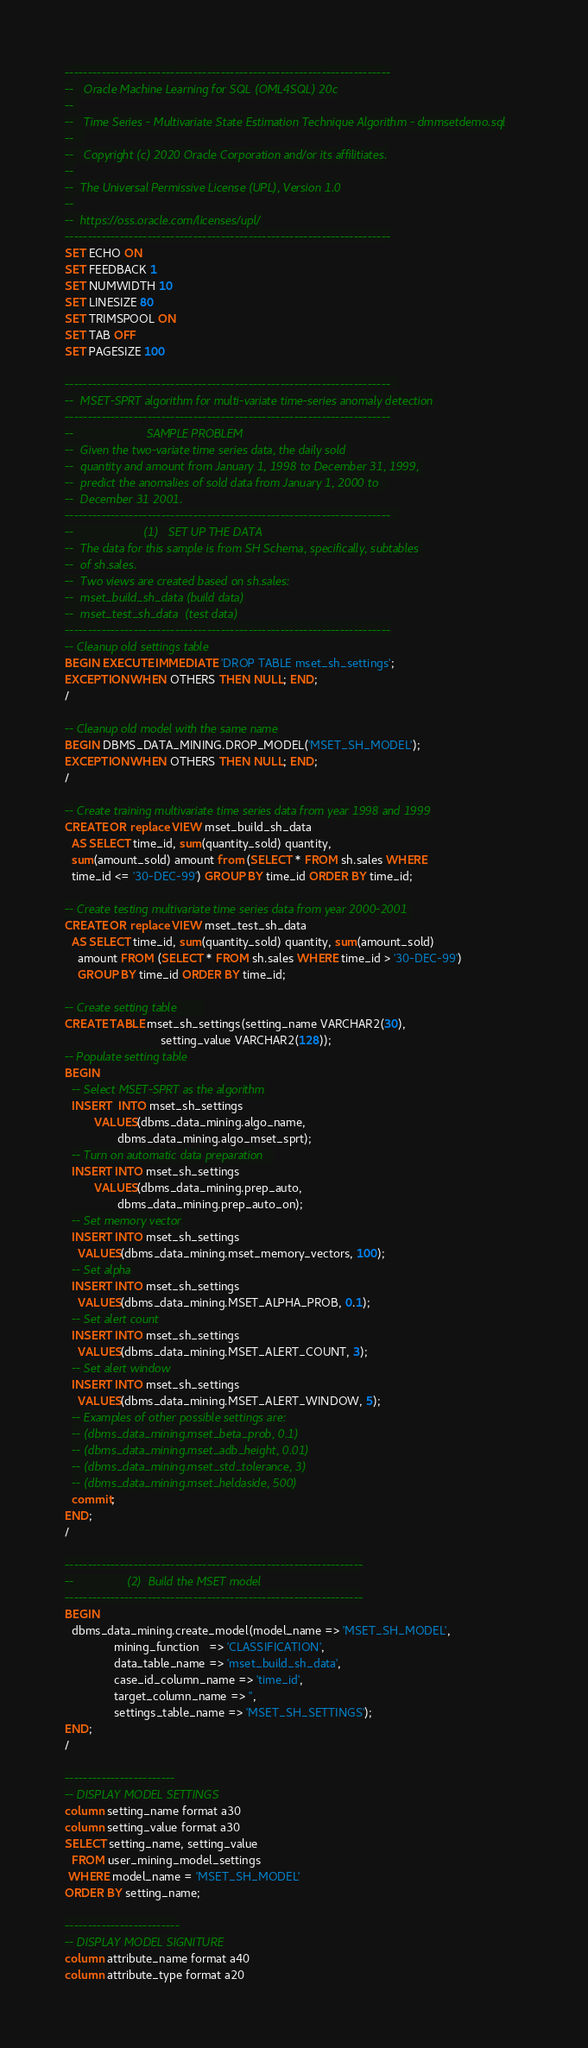Convert code to text. <code><loc_0><loc_0><loc_500><loc_500><_SQL_>-----------------------------------------------------------------------
--   Oracle Machine Learning for SQL (OML4SQL) 20c
-- 
--   Time Series - Multivariate State Estimation Technique Algorithm - dmmsetdemo.sql
--   
--   Copyright (c) 2020 Oracle Corporation and/or its affilitiates.
--
--  The Universal Permissive License (UPL), Version 1.0
--
--  https://oss.oracle.com/licenses/upl/
-----------------------------------------------------------------------
SET ECHO ON
SET FEEDBACK 1
SET NUMWIDTH 10
SET LINESIZE 80
SET TRIMSPOOL ON
SET TAB OFF
SET PAGESIZE 100  
  
-----------------------------------------------------------------------  
--  MSET-SPRT algorithm for multi-variate time-series anomaly detection
-----------------------------------------------------------------------
--                      SAMPLE PROBLEM
--  Given the two-variate time series data, the daily sold 
--  quantity and amount from January 1, 1998 to December 31, 1999, 
--  predict the anomalies of sold data from January 1, 2000 to  
--  December 31 2001.
-----------------------------------------------------------------------  
--                     (1)   SET UP THE DATA
--  The data for this sample is from SH Schema, specifically, subtables 
--  of sh.sales.
--  Two views are created based on sh.sales:
--  mset_build_sh_data (build data)
--  mset_test_sh_data  (test data)
-----------------------------------------------------------------------
-- Cleanup old settings table
BEGIN EXECUTE IMMEDIATE 'DROP TABLE mset_sh_settings';
EXCEPTION WHEN OTHERS THEN NULL; END;
/

-- Cleanup old model with the same name
BEGIN DBMS_DATA_MINING.DROP_MODEL('MSET_SH_MODEL');
EXCEPTION WHEN OTHERS THEN NULL; END;
/

-- Create training multivariate time series data from year 1998 and 1999
CREATE OR replace VIEW mset_build_sh_data 
  AS SELECT time_id, sum(quantity_sold) quantity, 
  sum(amount_sold) amount from (SELECT * FROM sh.sales WHERE 
  time_id <= '30-DEC-99') GROUP BY time_id ORDER BY time_id;
       
-- Create testing multivariate time series data from year 2000-2001 
CREATE OR replace VIEW mset_test_sh_data 
  AS SELECT time_id, sum(quantity_sold) quantity, sum(amount_sold) 
    amount FROM (SELECT * FROM sh.sales WHERE time_id > '30-DEC-99') 
    GROUP BY time_id ORDER BY time_id;      
              
-- Create setting table        
CREATE TABLE mset_sh_settings(setting_name VARCHAR2(30), 
                             setting_value VARCHAR2(128));
-- Populate setting table
BEGIN
  -- Select MSET-SPRT as the algorithm
  INSERT  INTO mset_sh_settings
         VALUES(dbms_data_mining.algo_name,
                dbms_data_mining.algo_mset_sprt);
  -- Turn on automatic data preparation   
  INSERT INTO mset_sh_settings
         VALUES(dbms_data_mining.prep_auto,
                dbms_data_mining.prep_auto_on);
  -- Set memory vector
  INSERT INTO mset_sh_settings
    VALUES(dbms_data_mining.mset_memory_vectors, 100);
  -- Set alpha
  INSERT INTO mset_sh_settings
    VALUES(dbms_data_mining.MSET_ALPHA_PROB, 0.1);
  -- Set alert count
  INSERT INTO mset_sh_settings
    VALUES(dbms_data_mining.MSET_ALERT_COUNT, 3);
  -- Set alert window
  INSERT INTO mset_sh_settings
    VALUES(dbms_data_mining.MSET_ALERT_WINDOW, 5);  
  -- Examples of other possible settings are:
  -- (dbms_data_mining.mset_beta_prob, 0.1)
  -- (dbms_data_mining.mset_adb_height, 0.01)
  -- (dbms_data_mining.mset_std_tolerance, 3)
  -- (dbms_data_mining.mset_heldaside, 500)
  commit;  
END;
/

-----------------------------------------------------------------
--                (2)  Build the MSET model
-----------------------------------------------------------------
BEGIN
  dbms_data_mining.create_model(model_name => 'MSET_SH_MODEL',
               mining_function   => 'CLASSIFICATION',
               data_table_name => 'mset_build_sh_data',
               case_id_column_name => 'time_id',
               target_column_name => '',
               settings_table_name => 'MSET_SH_SETTINGS');
END;
/

------------------------
-- DISPLAY MODEL SETTINGS
column setting_name format a30
column setting_value format a30
SELECT setting_name, setting_value
  FROM user_mining_model_settings
 WHERE model_name = 'MSET_SH_MODEL'
ORDER BY setting_name;

-------------------------
-- DISPLAY MODEL SIGNITURE
column attribute_name format a40
column attribute_type format a20</code> 